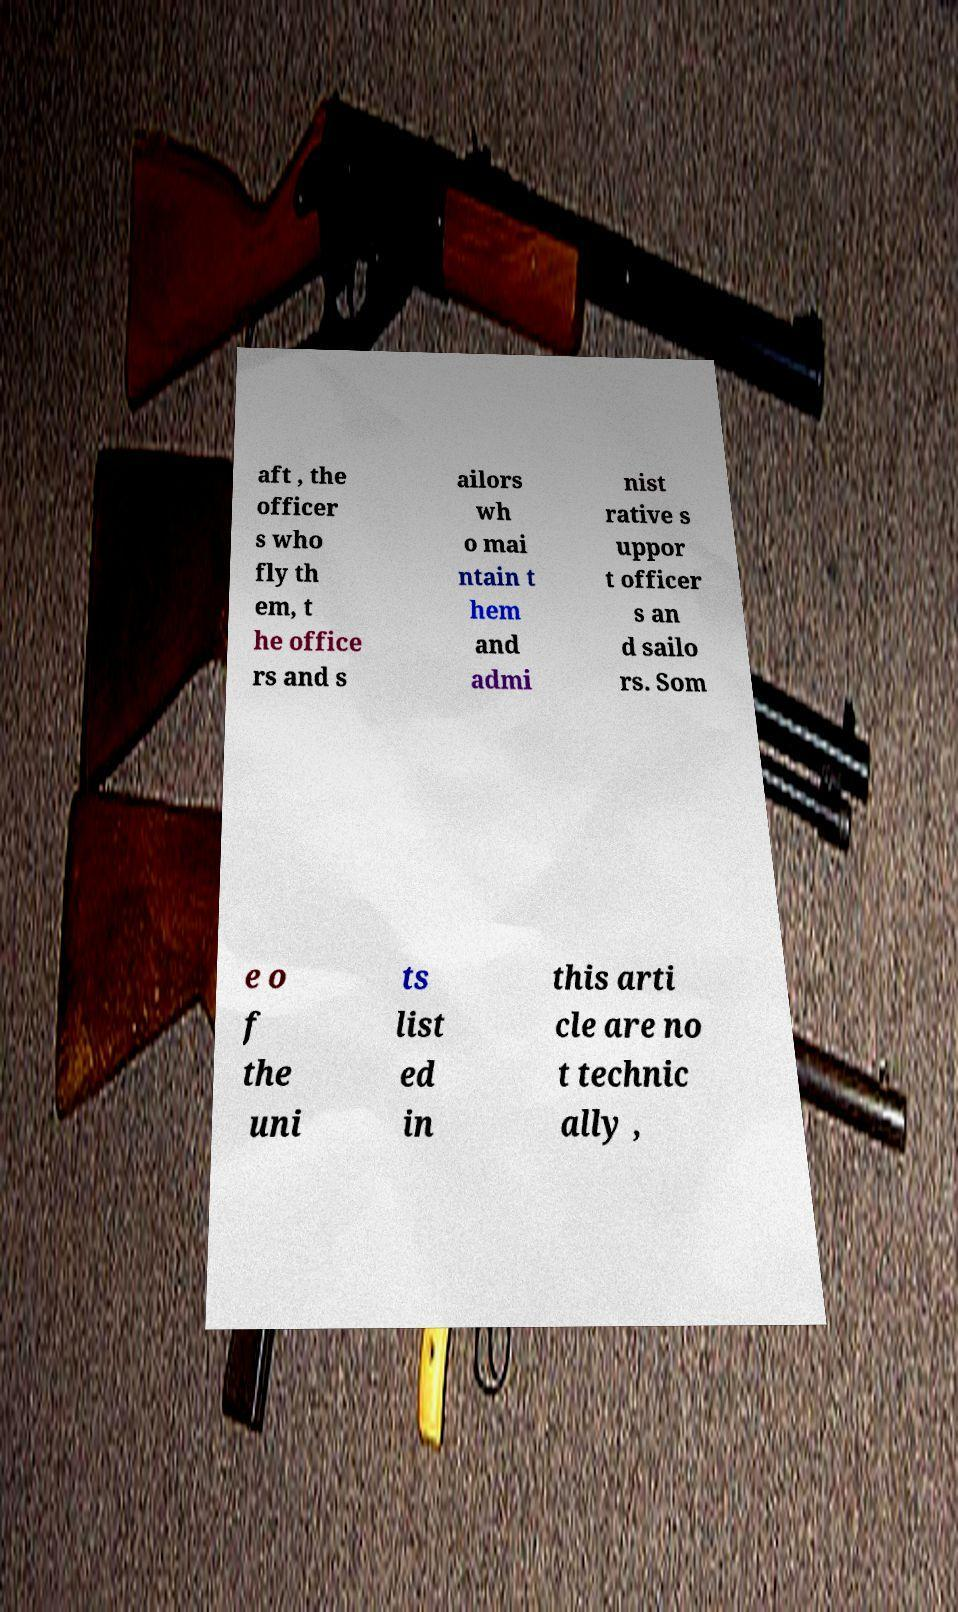Could you assist in decoding the text presented in this image and type it out clearly? aft , the officer s who fly th em, t he office rs and s ailors wh o mai ntain t hem and admi nist rative s uppor t officer s an d sailo rs. Som e o f the uni ts list ed in this arti cle are no t technic ally , 